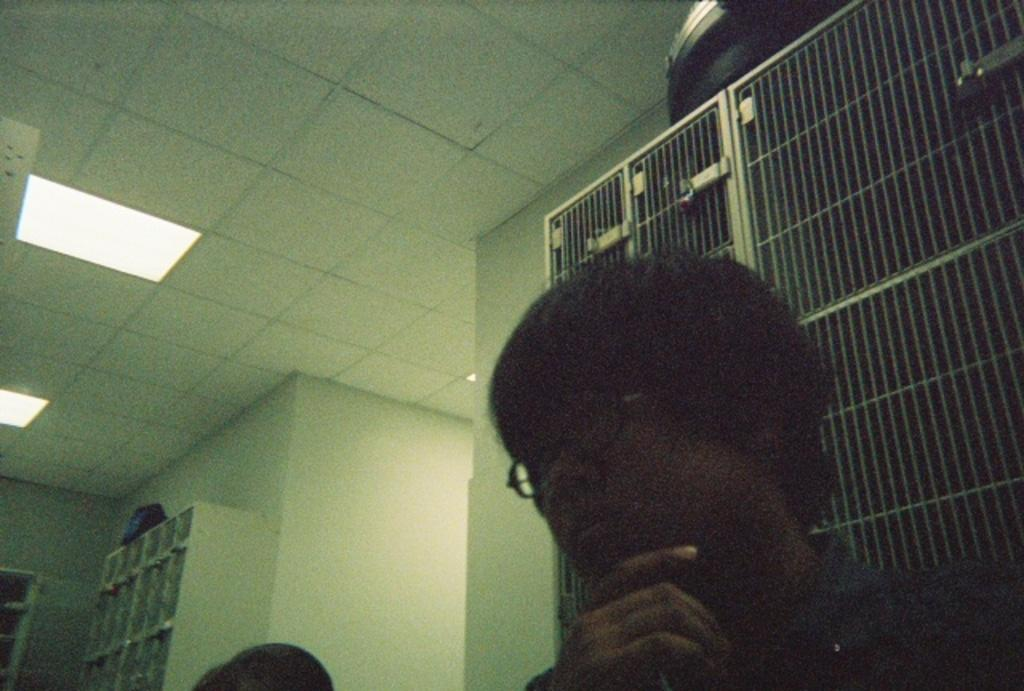How many people are in the image? There are two persons in the image. Where are the persons located in the image? The persons are at the bottom of the image. What can be seen in the background of the image? There is a wall in the background of the image. What is attached to the roof in the image? There are lights attached to the roof in the image. What is the chance of the persons winning a base in the image? There is no reference to a base or a competition in the image, so it's not possible to determine the chance of the persons winning anything. 